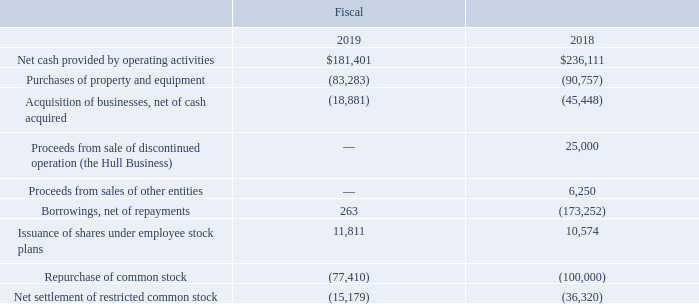Sources and Uses of Cash
Historically, our primary source of cash has been provided by operations. Other sources of cash in the past three fiscal years include proceeds from our Euro Term Loan used to finance our acquisition of Rofin, proceeds received from the sale of our stock through our employee stock purchase plan as well as borrowings under our revolving credit facility (‘‘Revolving Credit Facility’’). Our historical uses of cash have primarily been for acquisitions of businesses and technologies, the repurchase of our common stock, capital expenditures and debt issuance costs. Supplemental information pertaining to our historical sources and uses of cash is presented as follows and should be read in conjunction with our Consolidated Statements of Cash Flows and notes thereto (in thousands):
Net cash provided by operating activities decreased by $54.7 million in fiscal 2019 compared to fiscal 2018. The decrease in cash provided by operating activities in fiscal 2019 was primarily due to lower net income and lower cash flows from income taxes payable and deferred taxes, partially offset by higher cash flows from accounts receivable, inventories, deferred revenue and accrued payroll. We believe that our existing cash, cash equivalents and short term investments combined with cash to be provided by operating activities and amounts available under our Revolving Credit Facility will be adequate to cover our working capital needs and planned capital expenditures for at least the next 12 months to the extent such items are known or are reasonably determinable based on current business and market conditions. However, we may elect to finance certain of our capital expenditure requirements through other sources of capital. We continue to follow our strategy to further strengthen our financial position by using available cash flow to fund operations.
What was the Net cash provided by operating activities in 2019?
Answer scale should be: thousand. $181,401. What was the  Purchases of property and equipment  in 2018?
Answer scale should be: thousand. (90,757). In which years are the uses of cash highlighted in the table? 2019, 2018. In which year was the Issuance of shares under employee stock plans larger? 11,811>10,574
Answer: 2019. What was the change in Issuance of shares under employee stock plans in 2019 from 2018?
Answer scale should be: thousand. 11,811-10,574
Answer: 1237. What was the percentage change in Issuance of shares under employee stock plans in 2019 from 2018?
Answer scale should be: percent. (11,811-10,574)/10,574
Answer: 11.7. 